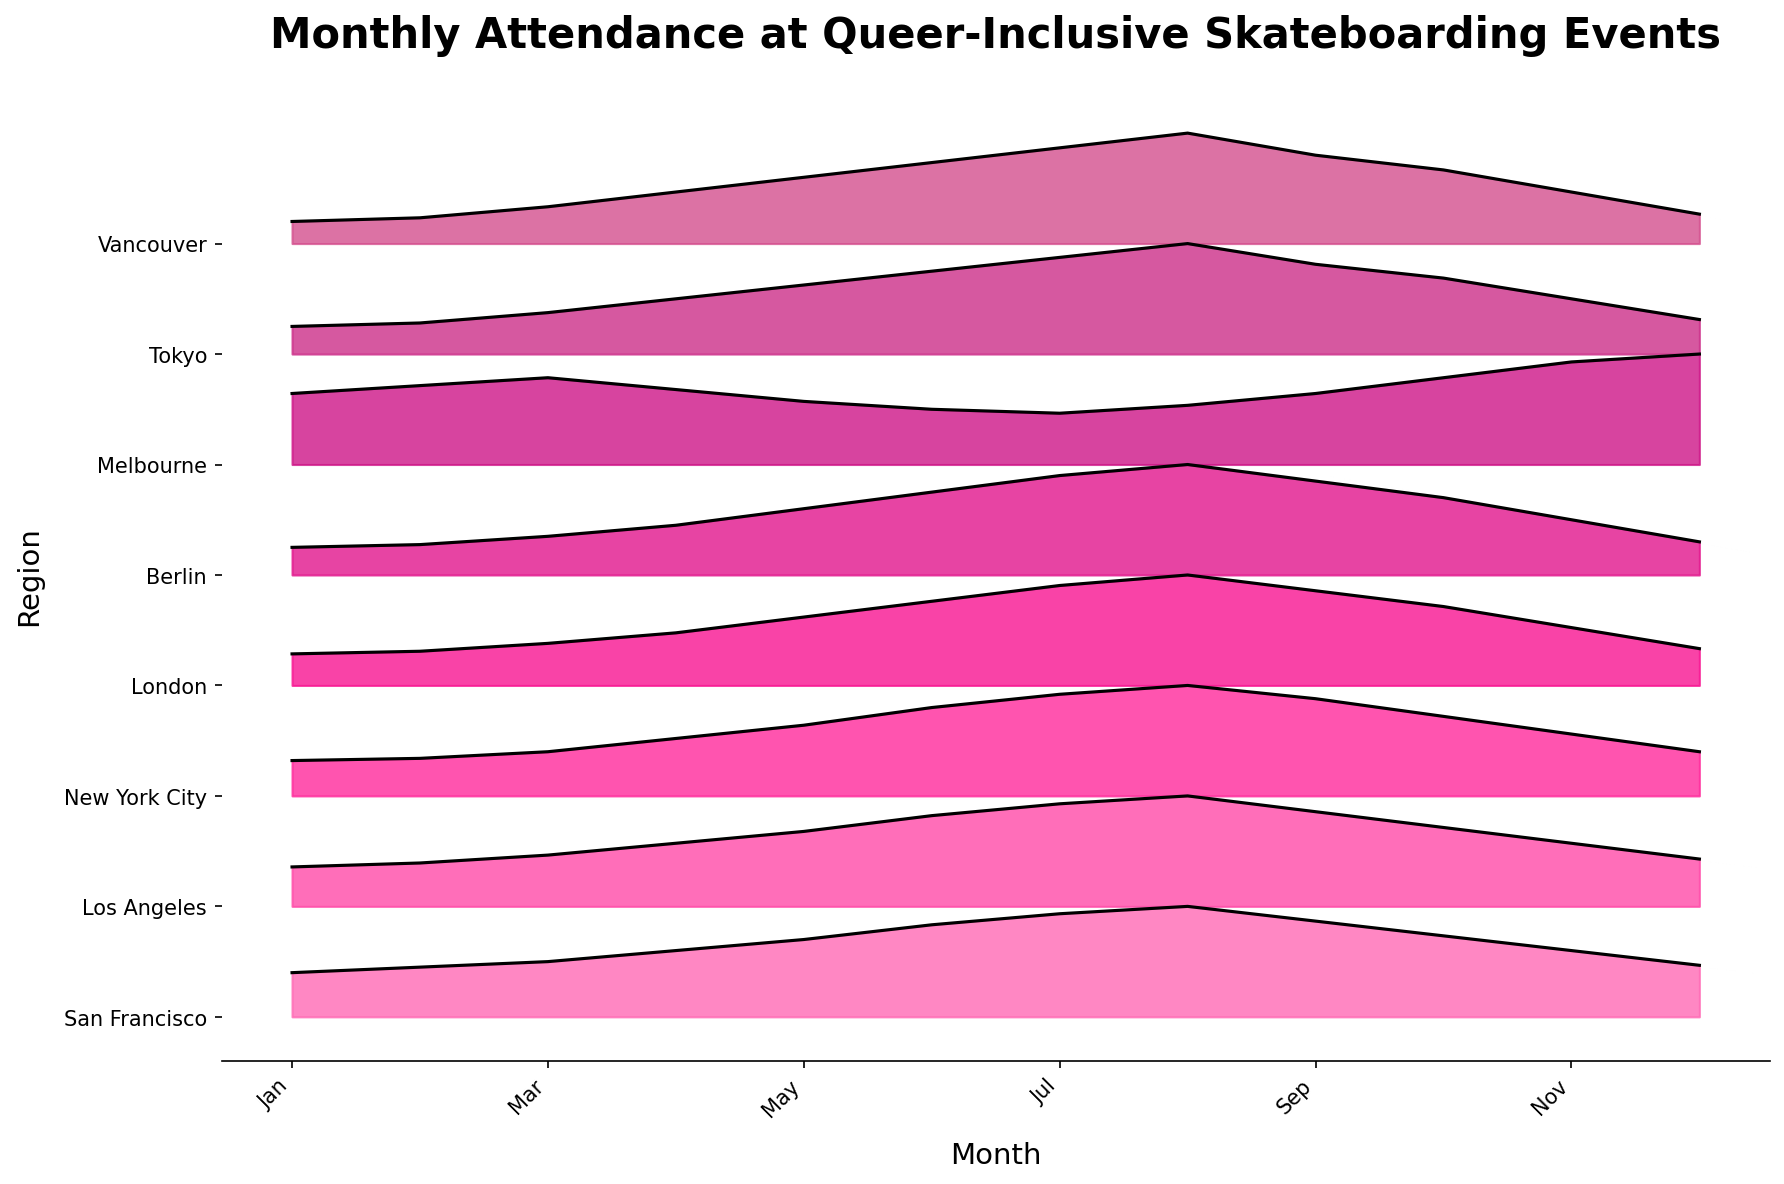What's the title of the figure? The title is usually placed at the top of the figure for easy identification. In this case, it's written in bold and large font.
Answer: Monthly Attendance at Queer-Inclusive Skateboarding Events How many regions are represented in the figure? To get this, count the number of different y-axis tick labels, which represent the regions.
Answer: 8 Which region has the lowest attendance in December? Look at the December values for each region and find the one that has the smallest height.
Answer: Vancouver Which region shows the highest peak in July? Identify the region with the highest filled area in the month of July by comparing the peaks.
Answer: San Francisco What is the attendance trend for London through the year? Examine London's curve throughout the months. Identify if it is increasing, decreasing, or fluctuating. London's plot starts with lower values which increase towards August and then decrease.
Answer: Increases till August, then decreases In which month does New York City have peak attendance, and how does this compare to Los Angeles? Find the month where New York City's ridgeline has the highest point. Compare this peak month with Los Angeles’s peak month to determine if they are the same or different.
Answer: Both peak in August Which region has a unique pattern compared to others, and what is it? Identify the region whose pattern deviates from the general trend of rising attendance towards the middle of the year and falling towards the end. Melbourne does not follow the rising trend in June, July, and August like the others.
Answer: Melbourne has a peak in December What can you say about attendance trends in San Francisco and Vancouver from January to December? Compare the two curves month by month. San Francisco consistently has higher attendance, showing a steady climb and a slow decline, while Vancouver starts low, rises moderately and then drops again.
Answer: San Francisco increases then decreases; Vancouver starts low, slight rise, then drops Which two regions show attendance peaks at nearly the same months? Compare the peaks of each region's plot. New York City and Los Angeles both peak in August.
Answer: New York City and Los Angeles What's the distribution of months on the x-axis, and how are they labeled in terms of frequency? Examine the x-axis labels, noting how often the month names appear.
Answer: Every two months (Jan, Mar, May, Jul, Sep, Nov) 